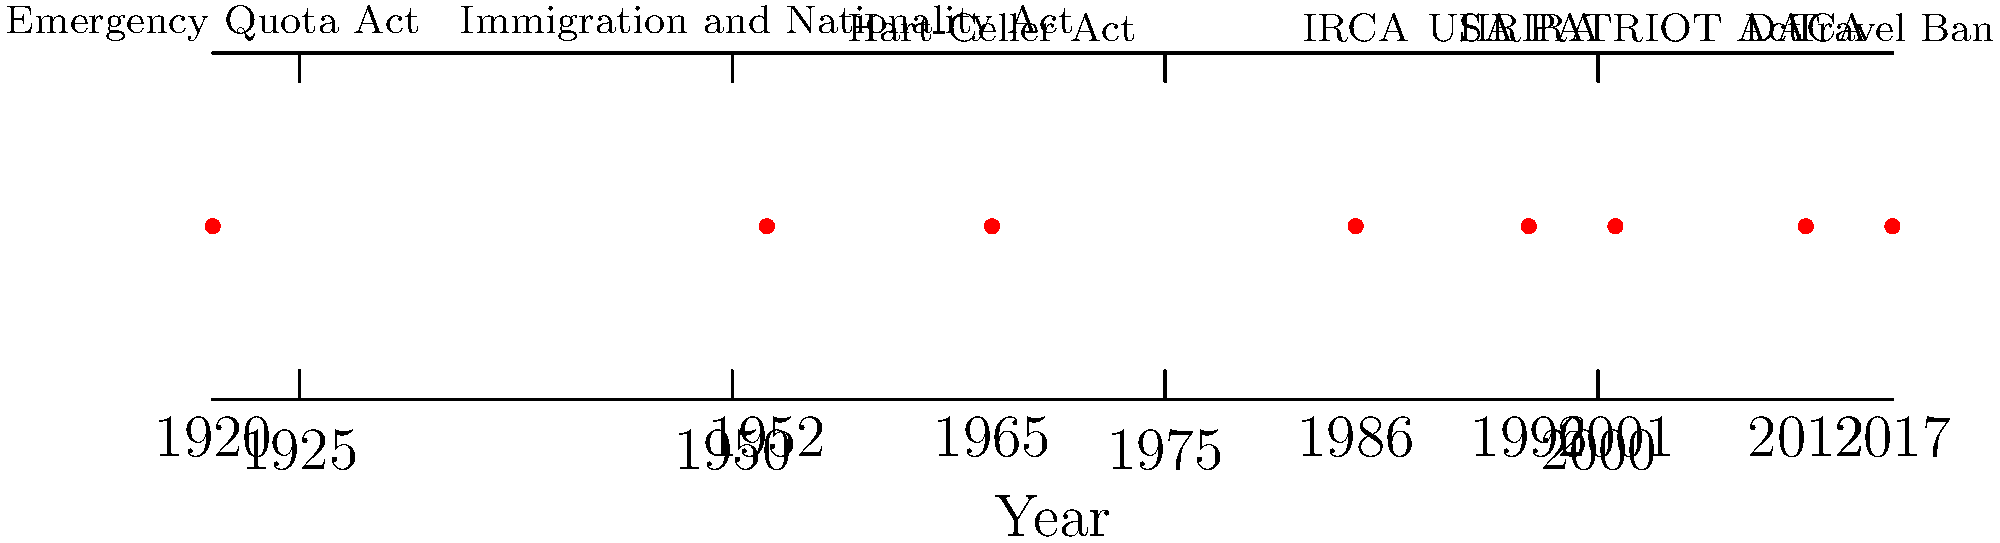As an immigration lawyer, which of the policies shown in the timeline had the most significant impact on family-based immigration to the United States, and how did it change the previous system? To answer this question, we need to analyze each policy's impact on family-based immigration:

1. 1920 Emergency Quota Act: Limited immigration based on national origin quotas.
2. 1952 Immigration and Nationality Act: Maintained national origin quota system.
3. 1965 Hart-Celler Act: This act had the most significant impact on family-based immigration.
   - Eliminated national origin quotas
   - Established a new system prioritizing family reunification
   - Created preference categories for family-sponsored immigration
   - Introduced numerical limits on Western Hemisphere immigration
4. 1986 IRCA: Focused on illegal immigration and employer sanctions.
5. 1996 IIRIRA: Addressed illegal immigration and enforcement.
6. 2001 USA PATRIOT Act: Focused on security measures.
7. 2012 DACA: Addressed young undocumented immigrants.
8. 2017 Travel Ban: Restricted entry from certain countries.

The 1965 Hart-Celler Act fundamentally changed the U.S. immigration system by shifting from a national origins quota system to a family reunification-based system. This act:
- Eliminated national origin, race, and ancestry as basis for immigration
- Established a seven-category preference system for family-sponsored immigration
- Set numerical limits on immigration from the Western Hemisphere for the first time
- Prioritized the reunification of immigrant families

This policy had the most profound and lasting impact on family-based immigration, shaping the modern U.S. immigration system.
Answer: 1965 Hart-Celler Act; shifted from national origins quota to family reunification-based system 